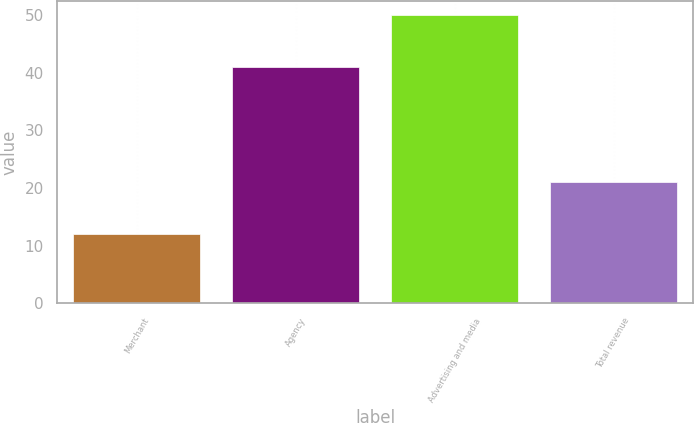<chart> <loc_0><loc_0><loc_500><loc_500><bar_chart><fcel>Merchant<fcel>Agency<fcel>Advertising and media<fcel>Total revenue<nl><fcel>12<fcel>41<fcel>50<fcel>21<nl></chart> 